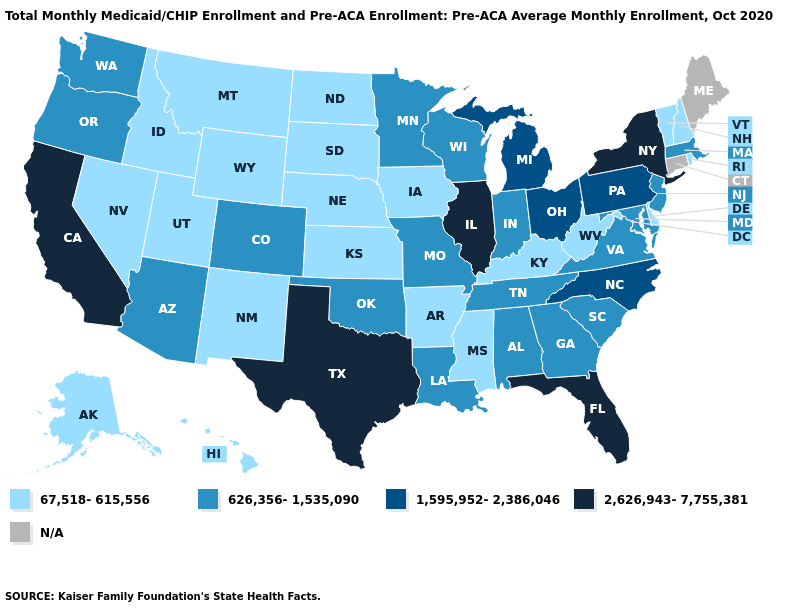Does the first symbol in the legend represent the smallest category?
Keep it brief. Yes. What is the highest value in states that border West Virginia?
Be succinct. 1,595,952-2,386,046. Which states have the lowest value in the USA?
Quick response, please. Alaska, Arkansas, Delaware, Hawaii, Idaho, Iowa, Kansas, Kentucky, Mississippi, Montana, Nebraska, Nevada, New Hampshire, New Mexico, North Dakota, Rhode Island, South Dakota, Utah, Vermont, West Virginia, Wyoming. Name the states that have a value in the range 2,626,943-7,755,381?
Give a very brief answer. California, Florida, Illinois, New York, Texas. What is the value of New Hampshire?
Concise answer only. 67,518-615,556. Which states have the lowest value in the USA?
Write a very short answer. Alaska, Arkansas, Delaware, Hawaii, Idaho, Iowa, Kansas, Kentucky, Mississippi, Montana, Nebraska, Nevada, New Hampshire, New Mexico, North Dakota, Rhode Island, South Dakota, Utah, Vermont, West Virginia, Wyoming. Name the states that have a value in the range 1,595,952-2,386,046?
Quick response, please. Michigan, North Carolina, Ohio, Pennsylvania. What is the lowest value in the USA?
Be succinct. 67,518-615,556. Which states have the lowest value in the Northeast?
Answer briefly. New Hampshire, Rhode Island, Vermont. What is the highest value in the West ?
Write a very short answer. 2,626,943-7,755,381. Name the states that have a value in the range 2,626,943-7,755,381?
Short answer required. California, Florida, Illinois, New York, Texas. Which states have the highest value in the USA?
Keep it brief. California, Florida, Illinois, New York, Texas. Name the states that have a value in the range 626,356-1,535,090?
Keep it brief. Alabama, Arizona, Colorado, Georgia, Indiana, Louisiana, Maryland, Massachusetts, Minnesota, Missouri, New Jersey, Oklahoma, Oregon, South Carolina, Tennessee, Virginia, Washington, Wisconsin. Name the states that have a value in the range 67,518-615,556?
Keep it brief. Alaska, Arkansas, Delaware, Hawaii, Idaho, Iowa, Kansas, Kentucky, Mississippi, Montana, Nebraska, Nevada, New Hampshire, New Mexico, North Dakota, Rhode Island, South Dakota, Utah, Vermont, West Virginia, Wyoming. 